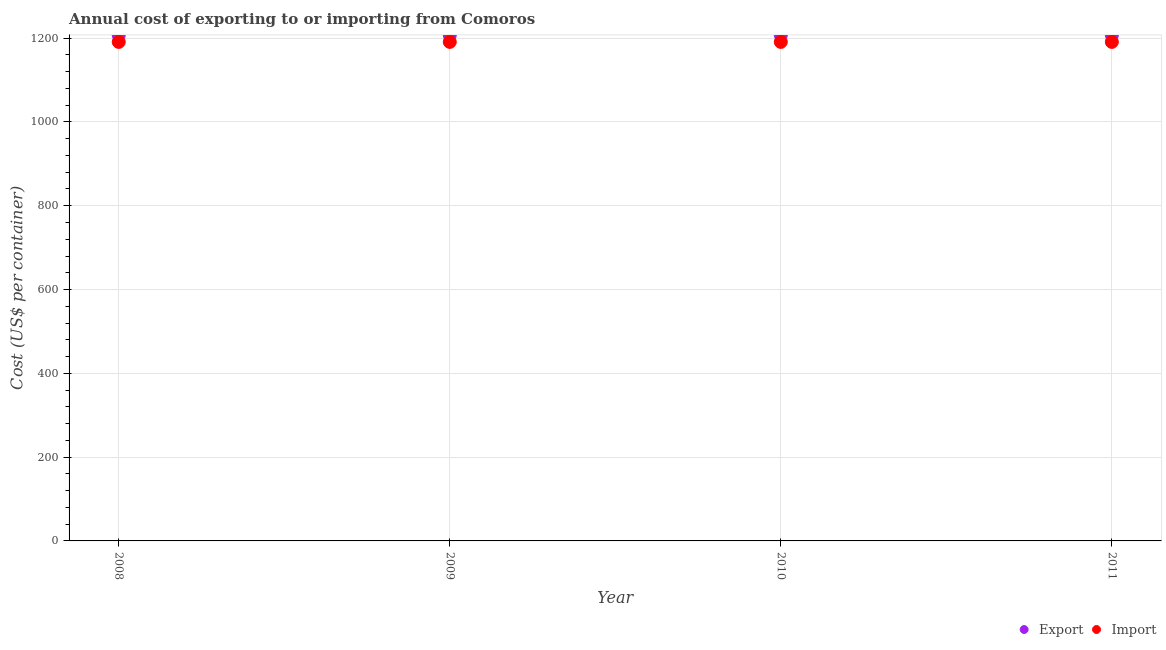What is the import cost in 2008?
Provide a short and direct response. 1191. Across all years, what is the maximum export cost?
Offer a very short reply. 1207. Across all years, what is the minimum export cost?
Ensure brevity in your answer.  1207. In which year was the import cost maximum?
Give a very brief answer. 2008. What is the total import cost in the graph?
Make the answer very short. 4764. What is the difference between the import cost in 2010 and the export cost in 2008?
Keep it short and to the point. -16. What is the average import cost per year?
Provide a succinct answer. 1191. In the year 2010, what is the difference between the import cost and export cost?
Your answer should be compact. -16. In how many years, is the import cost greater than 80 US$?
Ensure brevity in your answer.  4. Is the difference between the import cost in 2008 and 2011 greater than the difference between the export cost in 2008 and 2011?
Offer a terse response. No. Is the export cost strictly greater than the import cost over the years?
Your answer should be very brief. Yes. How many years are there in the graph?
Offer a very short reply. 4. Does the graph contain any zero values?
Offer a terse response. No. Does the graph contain grids?
Provide a succinct answer. Yes. What is the title of the graph?
Your answer should be very brief. Annual cost of exporting to or importing from Comoros. What is the label or title of the X-axis?
Offer a terse response. Year. What is the label or title of the Y-axis?
Provide a succinct answer. Cost (US$ per container). What is the Cost (US$ per container) in Export in 2008?
Ensure brevity in your answer.  1207. What is the Cost (US$ per container) in Import in 2008?
Provide a succinct answer. 1191. What is the Cost (US$ per container) in Export in 2009?
Your response must be concise. 1207. What is the Cost (US$ per container) in Import in 2009?
Make the answer very short. 1191. What is the Cost (US$ per container) of Export in 2010?
Ensure brevity in your answer.  1207. What is the Cost (US$ per container) of Import in 2010?
Offer a terse response. 1191. What is the Cost (US$ per container) in Export in 2011?
Make the answer very short. 1207. What is the Cost (US$ per container) of Import in 2011?
Your answer should be compact. 1191. Across all years, what is the maximum Cost (US$ per container) of Export?
Keep it short and to the point. 1207. Across all years, what is the maximum Cost (US$ per container) of Import?
Your answer should be very brief. 1191. Across all years, what is the minimum Cost (US$ per container) in Export?
Offer a terse response. 1207. Across all years, what is the minimum Cost (US$ per container) in Import?
Your response must be concise. 1191. What is the total Cost (US$ per container) of Export in the graph?
Offer a terse response. 4828. What is the total Cost (US$ per container) of Import in the graph?
Your answer should be compact. 4764. What is the difference between the Cost (US$ per container) in Export in 2008 and that in 2009?
Make the answer very short. 0. What is the difference between the Cost (US$ per container) of Export in 2008 and that in 2010?
Your answer should be compact. 0. What is the difference between the Cost (US$ per container) of Export in 2008 and that in 2011?
Your answer should be compact. 0. What is the difference between the Cost (US$ per container) of Import in 2008 and that in 2011?
Offer a terse response. 0. What is the difference between the Cost (US$ per container) in Export in 2009 and that in 2010?
Offer a terse response. 0. What is the difference between the Cost (US$ per container) in Import in 2010 and that in 2011?
Ensure brevity in your answer.  0. What is the difference between the Cost (US$ per container) in Export in 2008 and the Cost (US$ per container) in Import in 2010?
Provide a short and direct response. 16. What is the difference between the Cost (US$ per container) of Export in 2009 and the Cost (US$ per container) of Import in 2010?
Make the answer very short. 16. What is the difference between the Cost (US$ per container) of Export in 2009 and the Cost (US$ per container) of Import in 2011?
Ensure brevity in your answer.  16. What is the difference between the Cost (US$ per container) of Export in 2010 and the Cost (US$ per container) of Import in 2011?
Make the answer very short. 16. What is the average Cost (US$ per container) of Export per year?
Provide a succinct answer. 1207. What is the average Cost (US$ per container) in Import per year?
Your answer should be compact. 1191. In the year 2008, what is the difference between the Cost (US$ per container) of Export and Cost (US$ per container) of Import?
Your answer should be very brief. 16. In the year 2009, what is the difference between the Cost (US$ per container) in Export and Cost (US$ per container) in Import?
Keep it short and to the point. 16. What is the ratio of the Cost (US$ per container) in Export in 2008 to that in 2010?
Provide a short and direct response. 1. What is the ratio of the Cost (US$ per container) of Import in 2009 to that in 2011?
Offer a terse response. 1. What is the difference between the highest and the second highest Cost (US$ per container) in Export?
Your response must be concise. 0. What is the difference between the highest and the second highest Cost (US$ per container) of Import?
Your response must be concise. 0. What is the difference between the highest and the lowest Cost (US$ per container) of Export?
Make the answer very short. 0. 